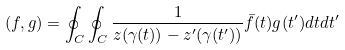Convert formula to latex. <formula><loc_0><loc_0><loc_500><loc_500>\left ( f , g \right ) = \oint _ { C } \oint _ { C } \frac { 1 } { z ( \gamma ( t ) ) - z ^ { \prime } ( \gamma ( t ^ { \prime } ) ) } \bar { f } ( t ) g ( t ^ { \prime } ) d t d t ^ { \prime }</formula> 